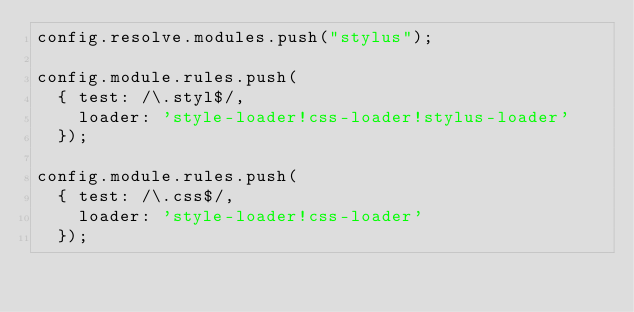<code> <loc_0><loc_0><loc_500><loc_500><_JavaScript_>config.resolve.modules.push("stylus");

config.module.rules.push(
  { test: /\.styl$/,
    loader: 'style-loader!css-loader!stylus-loader'
  });

config.module.rules.push(
  { test: /\.css$/,
    loader: 'style-loader!css-loader'
  });
</code> 